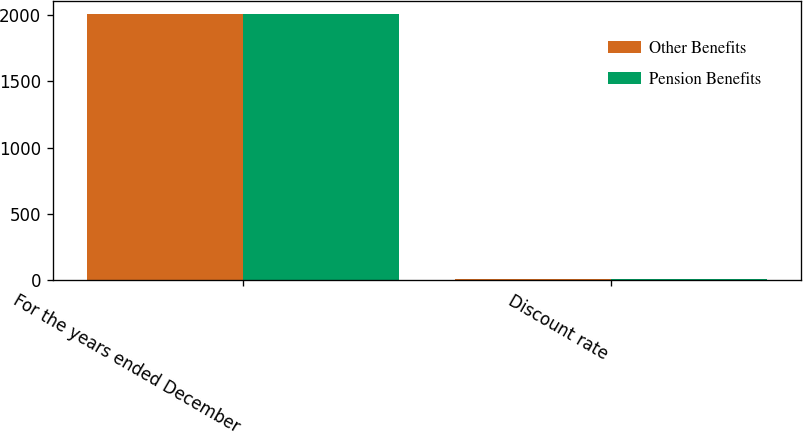<chart> <loc_0><loc_0><loc_500><loc_500><stacked_bar_chart><ecel><fcel>For the years ended December<fcel>Discount rate<nl><fcel>Other Benefits<fcel>2008<fcel>6.3<nl><fcel>Pension Benefits<fcel>2008<fcel>6.3<nl></chart> 